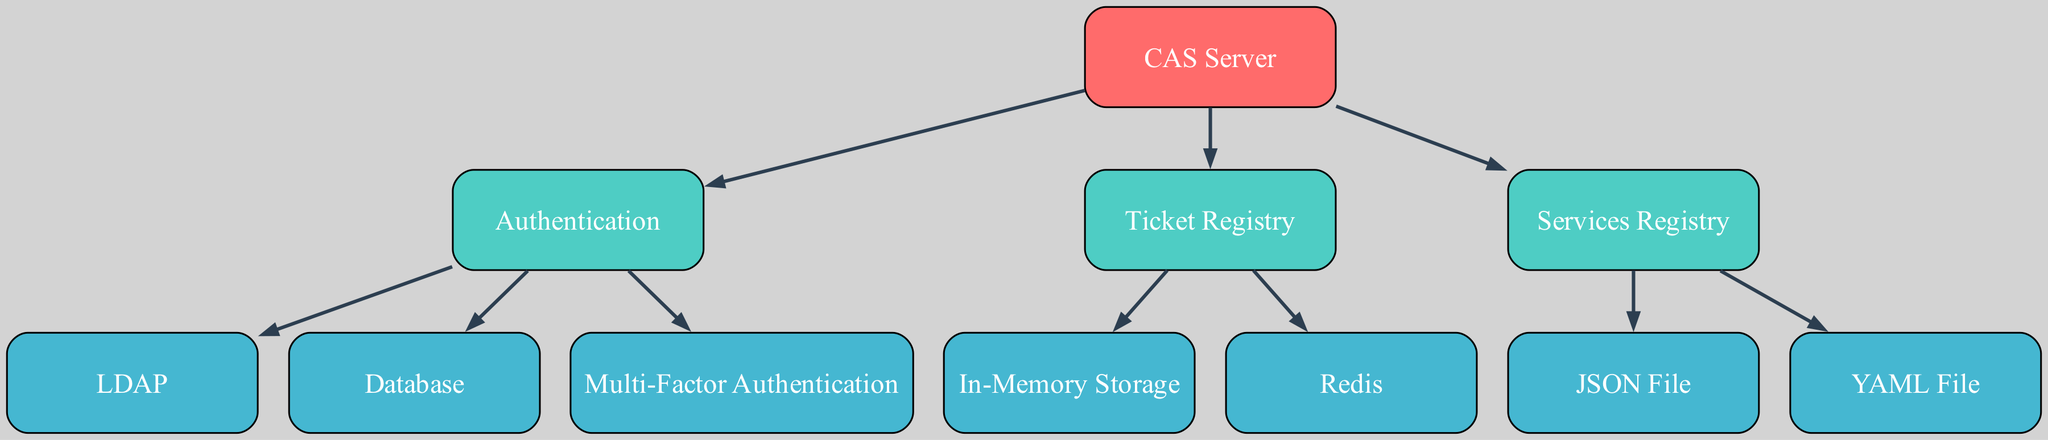What is the top-level component of the diagram? The diagram's top-level component is the CAS Server, which is depicted at level 0 and serves as the main entry point for the system structure.
Answer: CAS Server How many components are directly under the CAS Server? The CAS Server has three direct components beneath it: Authentication, Ticket Registry, and Services Registry.
Answer: Three What type of storage is associated with the Ticket Registry? The Ticket Registry is associated with two types of storage: In-Memory Storage and Redis, which are indicated as its sub-components.
Answer: In-Memory Storage and Redis Which component is used for handling multi-factor authentication? The component designated for handling multi-factor authentication is Multi-Factor Authentication, which is a sub-component of Authentication.
Answer: Multi-Factor Authentication How many services are registered under the Services Registry? Under the Services Registry, there are two types of services: JSON File and YAML File, indicating a total of two services registered.
Answer: Two What is the relationship between Authentication and Database? The relationship between Authentication and Database is that Database is a sub-component of Authentication, meaning it is part of the authentication process.
Answer: Sub-component What storage mechanism is associated with the Authentication component? The storage mechanism associated with the Authentication component includes LDAP and Database as sub-components meant for storing user data and authentication credentials.
Answer: LDAP and Database Which two types of files are included in the Services Registry? The two types of files included in the Services Registry are JSON File and YAML File, representing different formats for service configuration.
Answer: JSON File and YAML File How is the Ticket Registry linked to memory storage? The Ticket Registry is linked to In-Memory Storage because it directly connects to it as one of its sub-components.
Answer: In-Memory Storage 